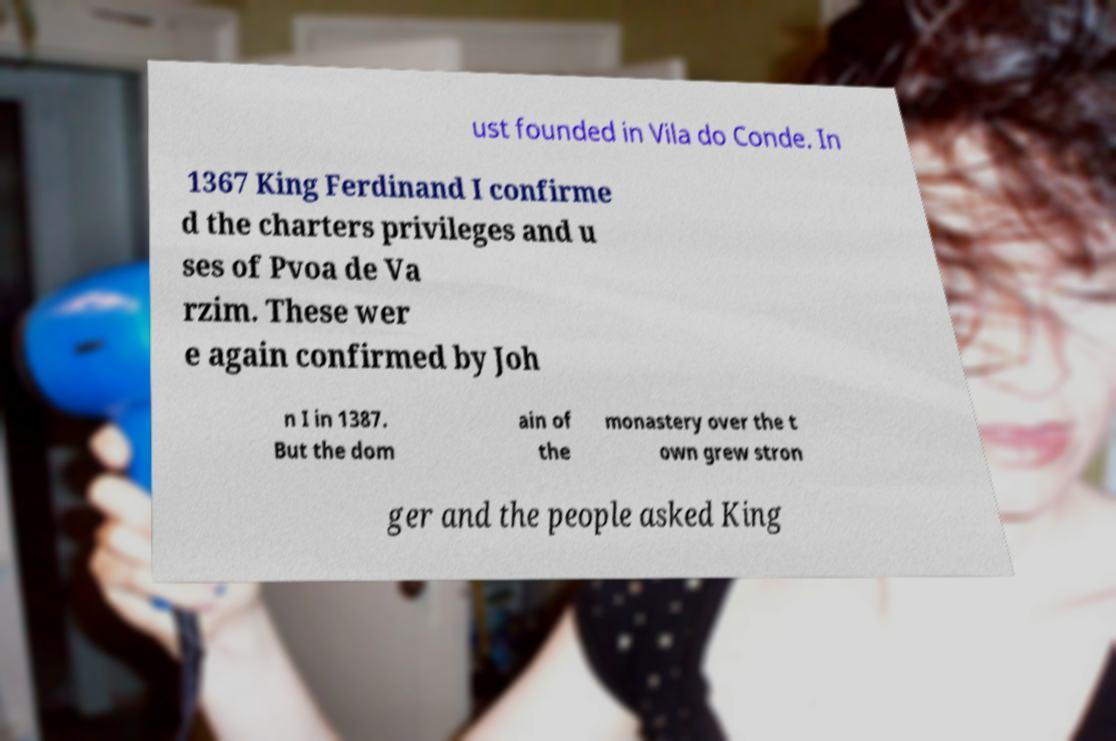I need the written content from this picture converted into text. Can you do that? ust founded in Vila do Conde. In 1367 King Ferdinand I confirme d the charters privileges and u ses of Pvoa de Va rzim. These wer e again confirmed by Joh n I in 1387. But the dom ain of the monastery over the t own grew stron ger and the people asked King 